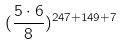<formula> <loc_0><loc_0><loc_500><loc_500>( \frac { 5 \cdot 6 } { 8 } ) ^ { 2 4 7 + 1 4 9 + 7 }</formula> 